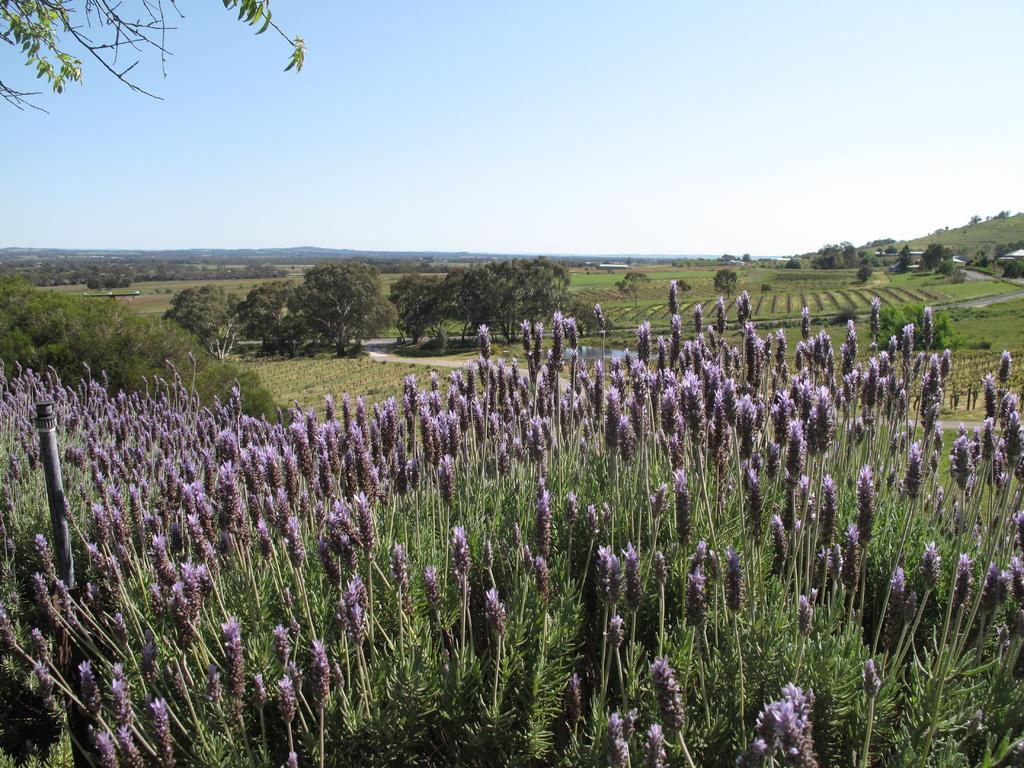Could you give a brief overview of what you see in this image? In the picture I can see plants, trees, the grass and some other objects on the ground. In the background I can see the sky. 